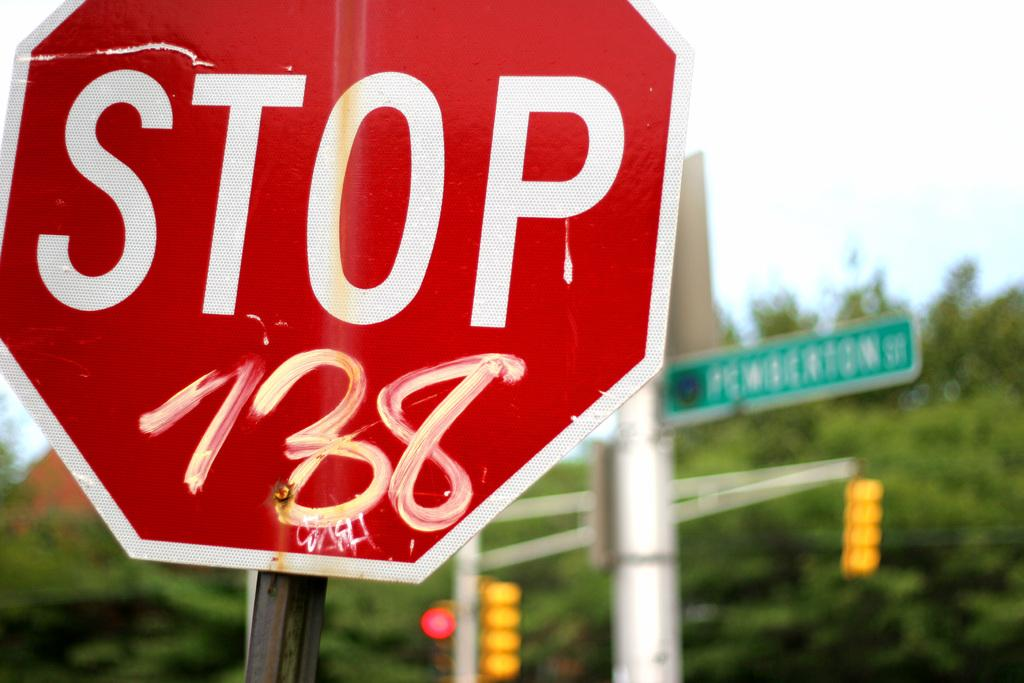Provide a one-sentence caption for the provided image. A STOP sign has white paint on it with that says 738. 